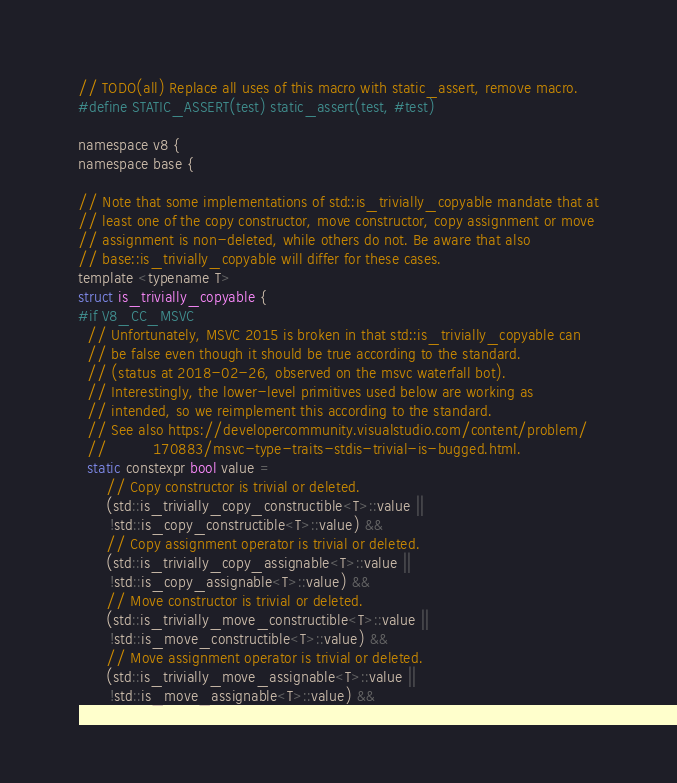<code> <loc_0><loc_0><loc_500><loc_500><_C_>

// TODO(all) Replace all uses of this macro with static_assert, remove macro.
#define STATIC_ASSERT(test) static_assert(test, #test)

namespace v8 {
namespace base {

// Note that some implementations of std::is_trivially_copyable mandate that at
// least one of the copy constructor, move constructor, copy assignment or move
// assignment is non-deleted, while others do not. Be aware that also
// base::is_trivially_copyable will differ for these cases.
template <typename T>
struct is_trivially_copyable {
#if V8_CC_MSVC
  // Unfortunately, MSVC 2015 is broken in that std::is_trivially_copyable can
  // be false even though it should be true according to the standard.
  // (status at 2018-02-26, observed on the msvc waterfall bot).
  // Interestingly, the lower-level primitives used below are working as
  // intended, so we reimplement this according to the standard.
  // See also https://developercommunity.visualstudio.com/content/problem/
  //          170883/msvc-type-traits-stdis-trivial-is-bugged.html.
  static constexpr bool value =
      // Copy constructor is trivial or deleted.
      (std::is_trivially_copy_constructible<T>::value ||
       !std::is_copy_constructible<T>::value) &&
      // Copy assignment operator is trivial or deleted.
      (std::is_trivially_copy_assignable<T>::value ||
       !std::is_copy_assignable<T>::value) &&
      // Move constructor is trivial or deleted.
      (std::is_trivially_move_constructible<T>::value ||
       !std::is_move_constructible<T>::value) &&
      // Move assignment operator is trivial or deleted.
      (std::is_trivially_move_assignable<T>::value ||
       !std::is_move_assignable<T>::value) &&</code> 